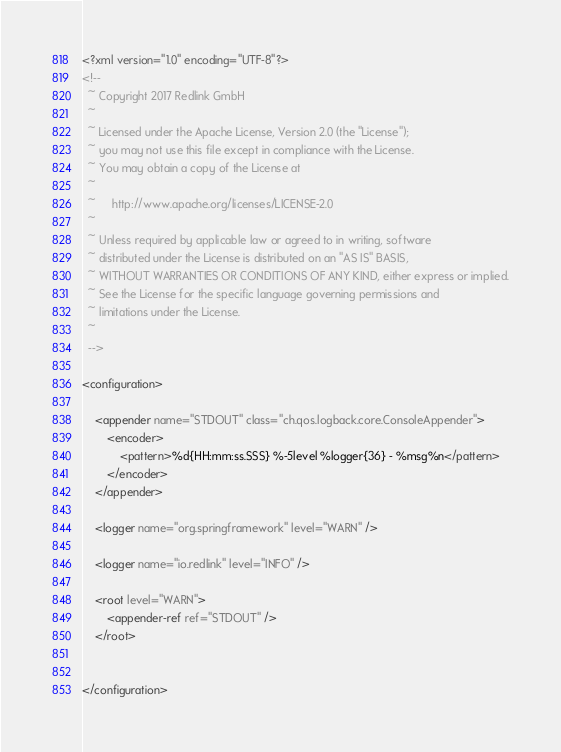<code> <loc_0><loc_0><loc_500><loc_500><_XML_><?xml version="1.0" encoding="UTF-8"?>
<!--
  ~ Copyright 2017 Redlink GmbH
  ~
  ~ Licensed under the Apache License, Version 2.0 (the "License");
  ~ you may not use this file except in compliance with the License.
  ~ You may obtain a copy of the License at
  ~
  ~     http://www.apache.org/licenses/LICENSE-2.0
  ~
  ~ Unless required by applicable law or agreed to in writing, software
  ~ distributed under the License is distributed on an "AS IS" BASIS,
  ~ WITHOUT WARRANTIES OR CONDITIONS OF ANY KIND, either express or implied.
  ~ See the License for the specific language governing permissions and
  ~ limitations under the License.
  ~
  -->

<configuration>

    <appender name="STDOUT" class="ch.qos.logback.core.ConsoleAppender">
        <encoder>
            <pattern>%d{HH:mm:ss.SSS} %-5level %logger{36} - %msg%n</pattern>
        </encoder>
    </appender>

    <logger name="org.springframework" level="WARN" />

    <logger name="io.redlink" level="INFO" />

    <root level="WARN">
        <appender-ref ref="STDOUT" />
    </root>


</configuration>
</code> 